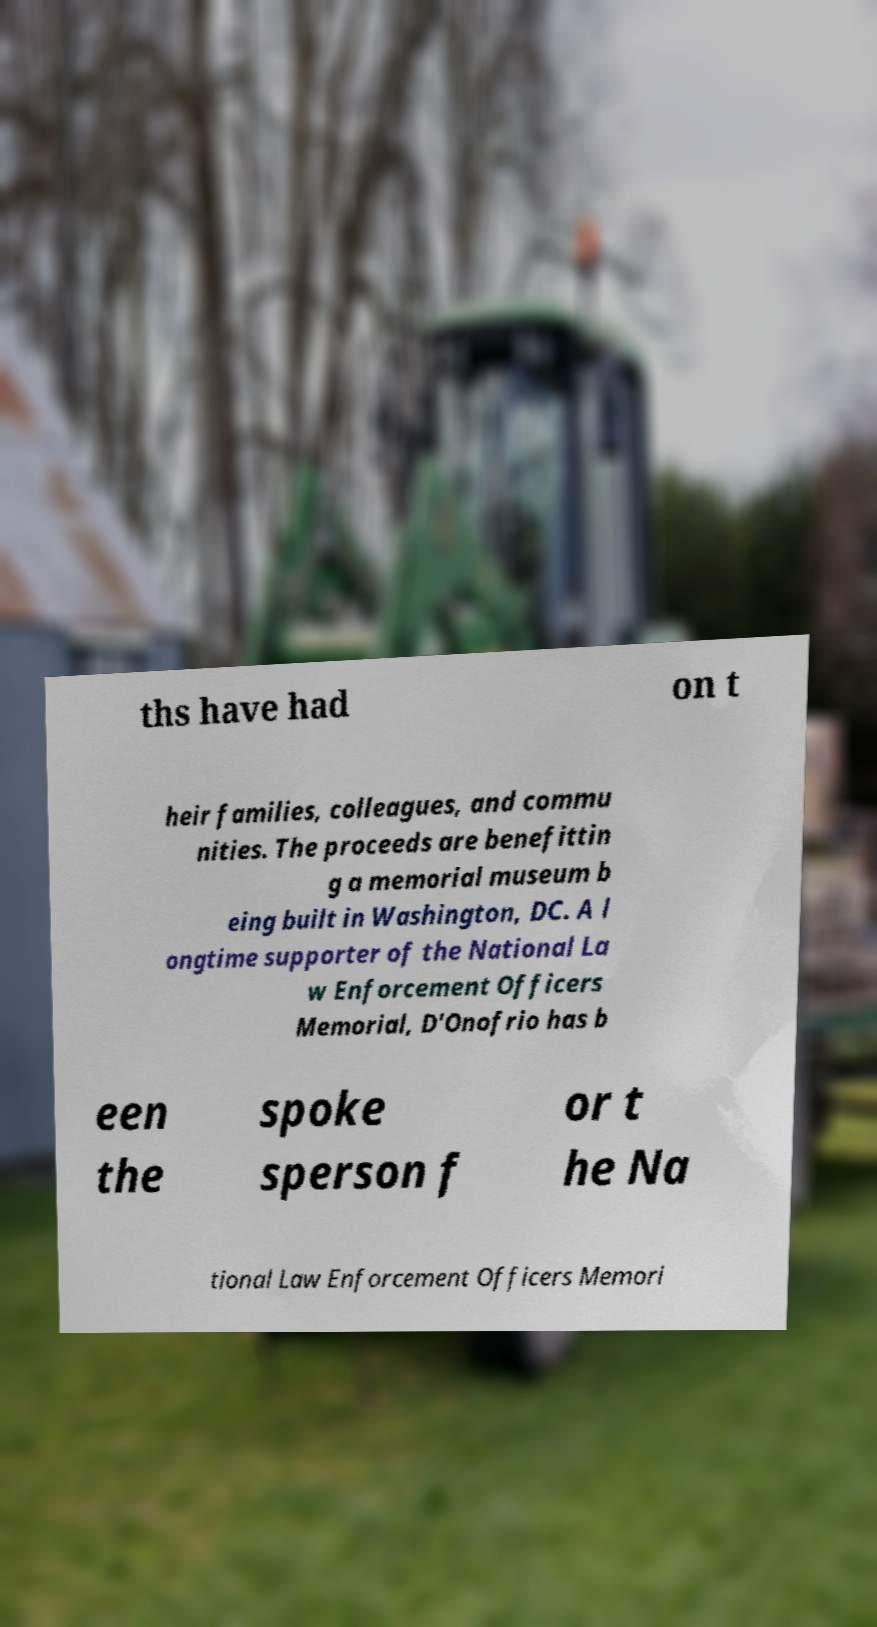I need the written content from this picture converted into text. Can you do that? ths have had on t heir families, colleagues, and commu nities. The proceeds are benefittin g a memorial museum b eing built in Washington, DC. A l ongtime supporter of the National La w Enforcement Officers Memorial, D'Onofrio has b een the spoke sperson f or t he Na tional Law Enforcement Officers Memori 